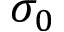Convert formula to latex. <formula><loc_0><loc_0><loc_500><loc_500>\sigma _ { 0 }</formula> 